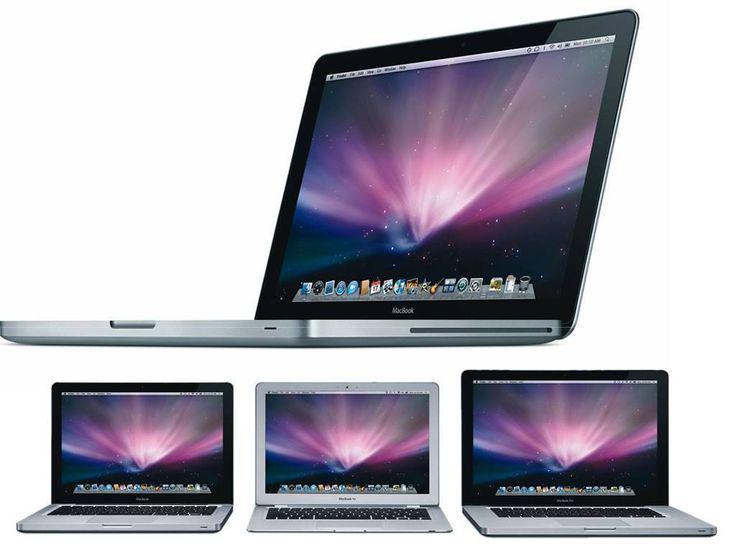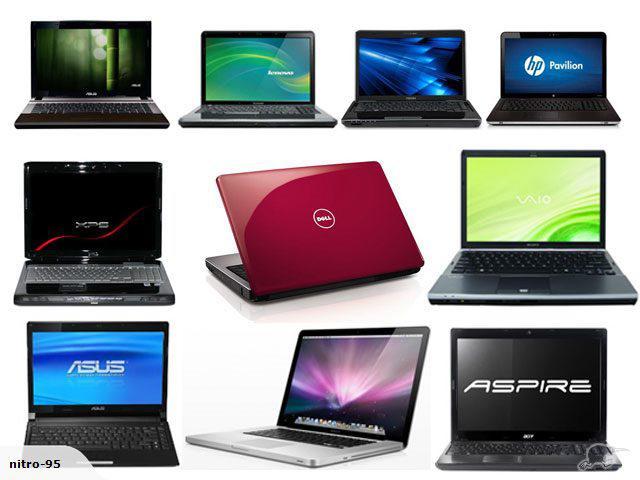The first image is the image on the left, the second image is the image on the right. For the images displayed, is the sentence "The right image contains three or more computers." factually correct? Answer yes or no. Yes. The first image is the image on the left, the second image is the image on the right. Given the left and right images, does the statement "Right image shows more devices with screens than left image." hold true? Answer yes or no. Yes. 